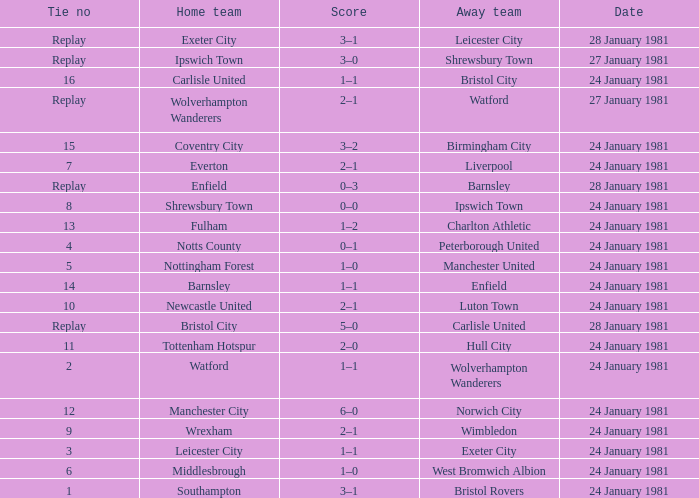Who is the home team with Liverpool as the away? Everton. 